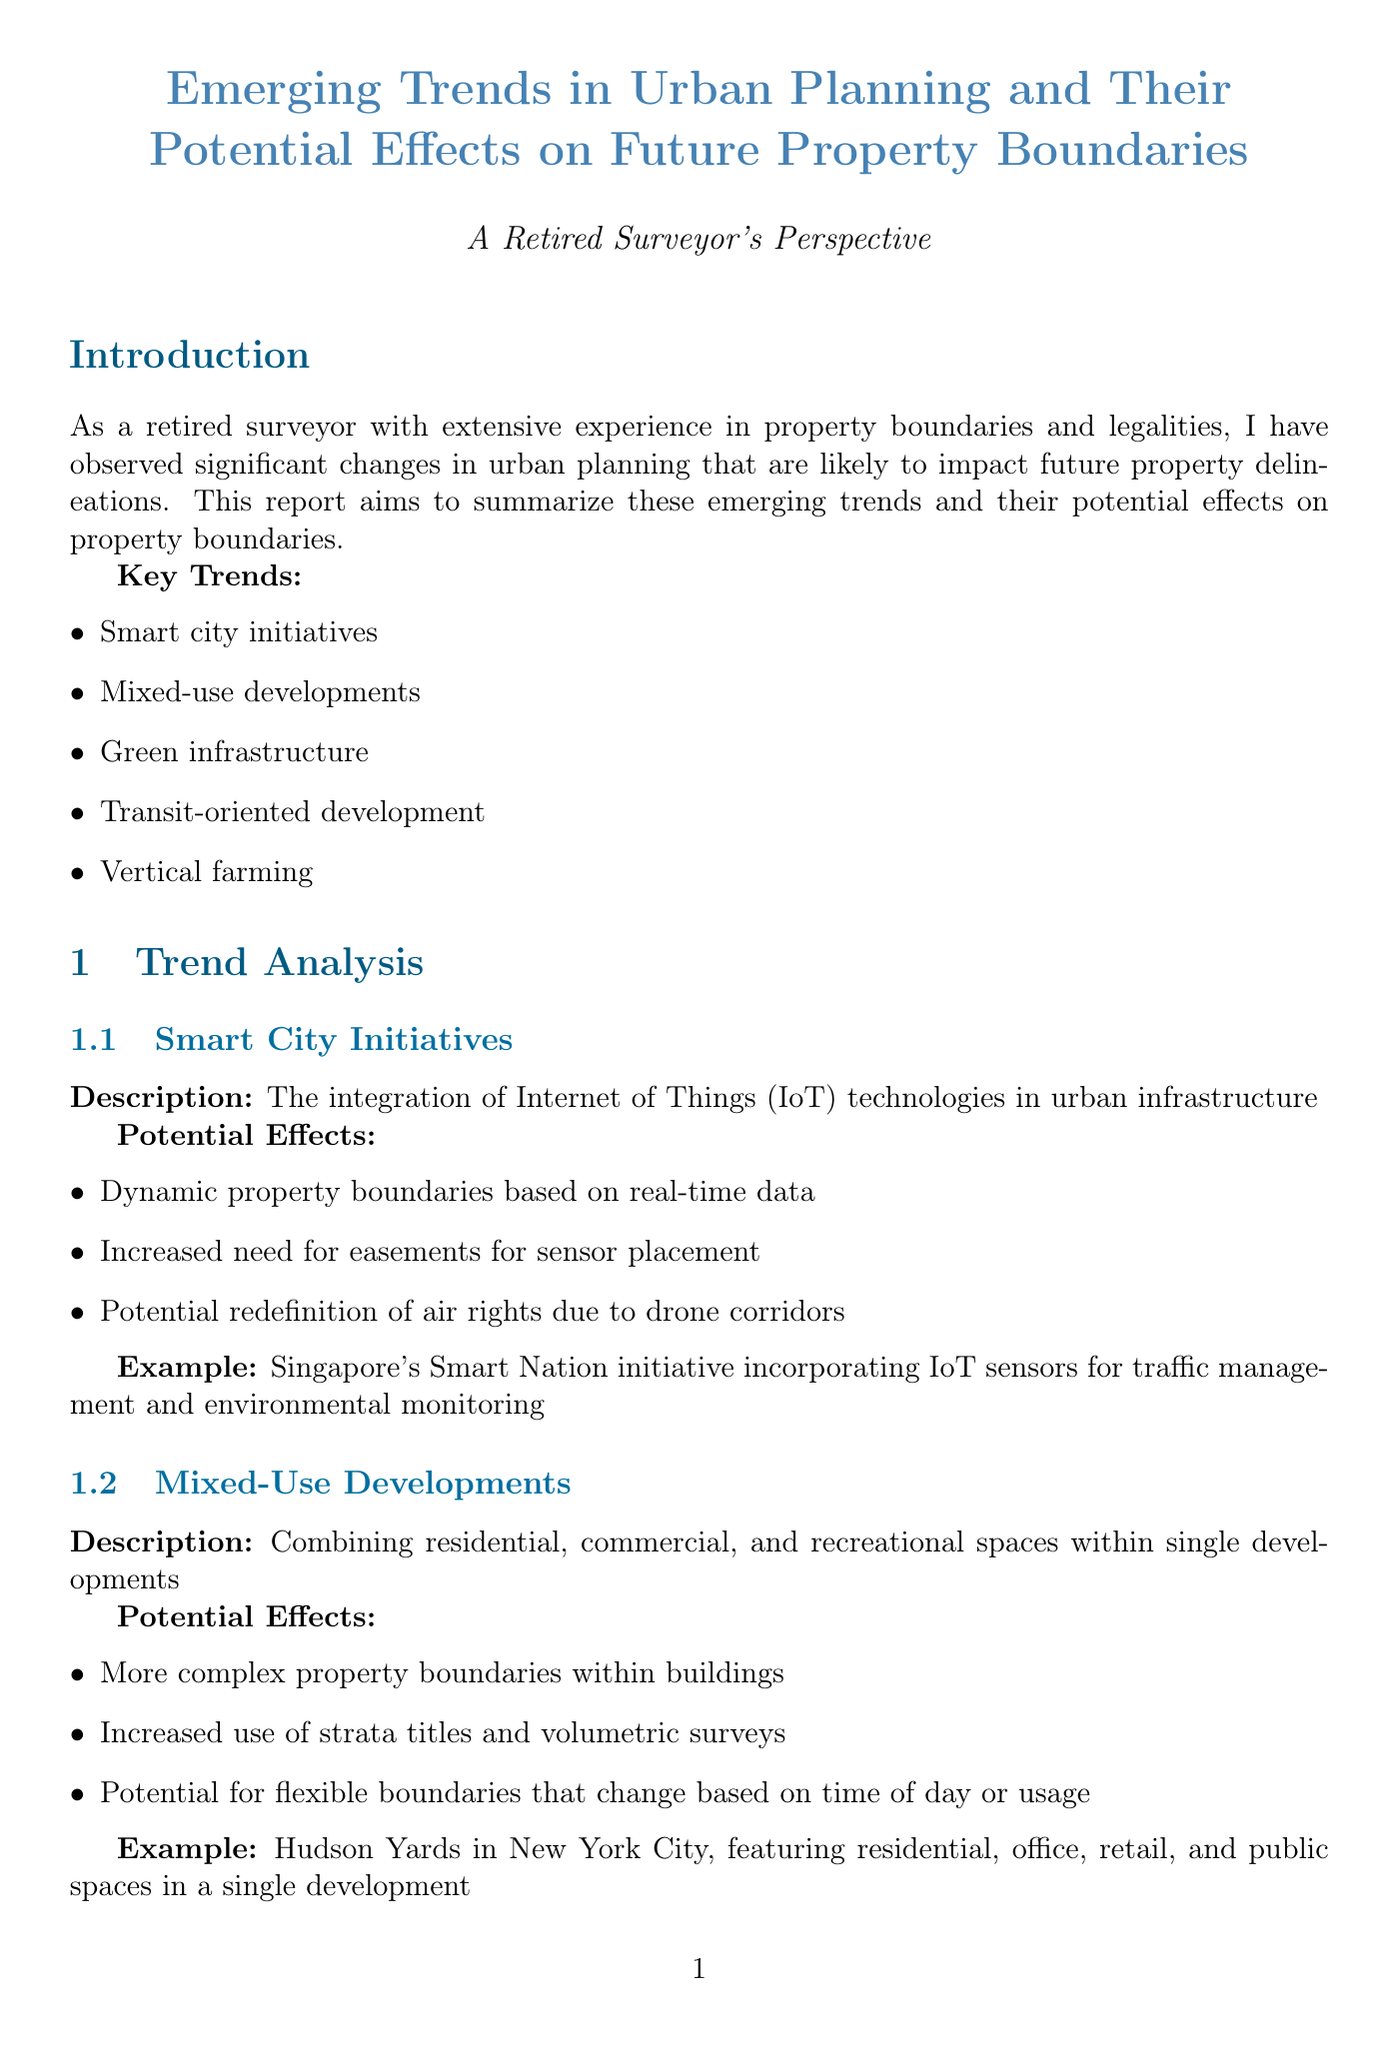What is the title of the report? The title of the report is provided at the beginning of the document, which encapsulates the central theme.
Answer: Emerging Trends in Urban Planning and Their Potential Effects on Future Property Boundaries How many key trends are identified in the introduction? The specific number of key trends is listed in the introduction section of the document.
Answer: Five What is one example of Smart City Initiatives mentioned? An example provided in the document illustrates a specific initiative implemented within a smart city context.
Answer: Singapore's Smart Nation initiative Which urban planning trend involves combining residential, commercial, and recreational spaces? The document describes a trend focused on the integration of various usages into cohesive communities.
Answer: Mixed-use developments What is a potential effect of Green Infrastructure on property boundaries? The document lists several potential impacts that innovations in green infrastructure may have on property delineations.
Answer: Creation of new easements for green corridors What legal change is suggested in the recommendations section? The recommendations section outlines specific actions that are proposed to adapt to emerging trends in urban planning.
Answer: Advocate for updates to property laws to accommodate new urban forms Which case study focuses on pedestrian and community spaces? The case studies section describes specific developments that exemplify the themes discussed in the report, including one that prioritizes public accessibility.
Answer: Barcelona Superblocks How should surveying practices adapt according to the conclusion? The conclusion emphasizes a requirement for changes in surveying methods due to new planning trends outlined in the report.
Answer: Invest in training for 3D cadastral surveying 